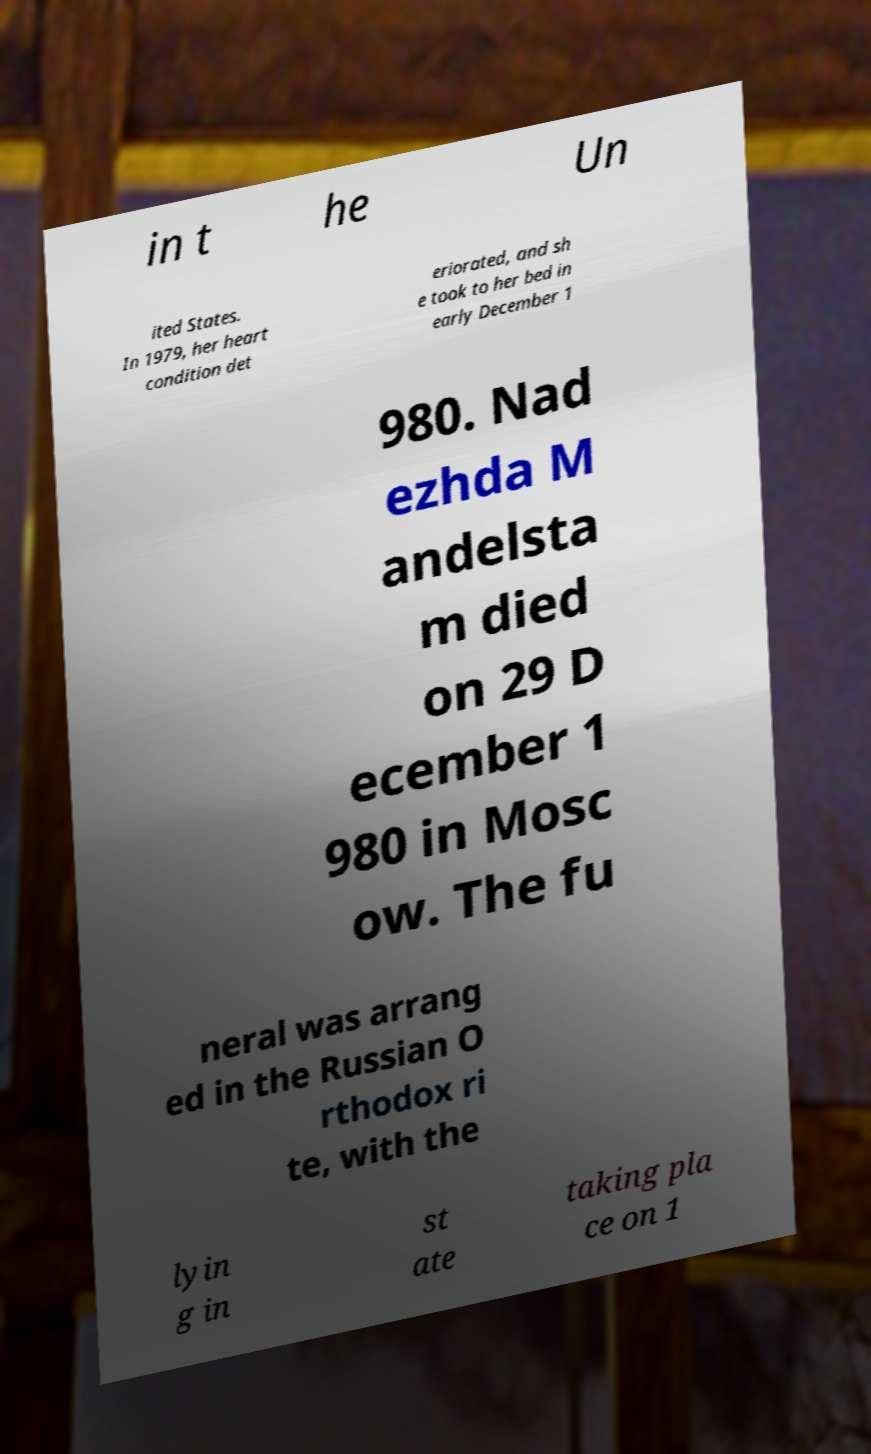Can you accurately transcribe the text from the provided image for me? in t he Un ited States. In 1979, her heart condition det eriorated, and sh e took to her bed in early December 1 980. Nad ezhda M andelsta m died on 29 D ecember 1 980 in Mosc ow. The fu neral was arrang ed in the Russian O rthodox ri te, with the lyin g in st ate taking pla ce on 1 